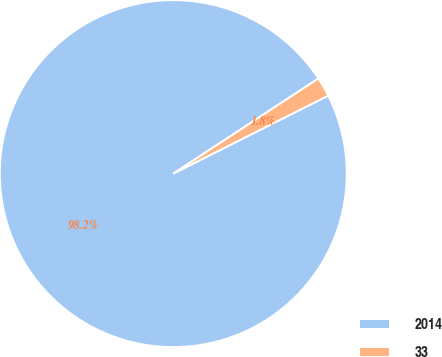<chart> <loc_0><loc_0><loc_500><loc_500><pie_chart><fcel>2014<fcel>33<nl><fcel>98.19%<fcel>1.81%<nl></chart> 